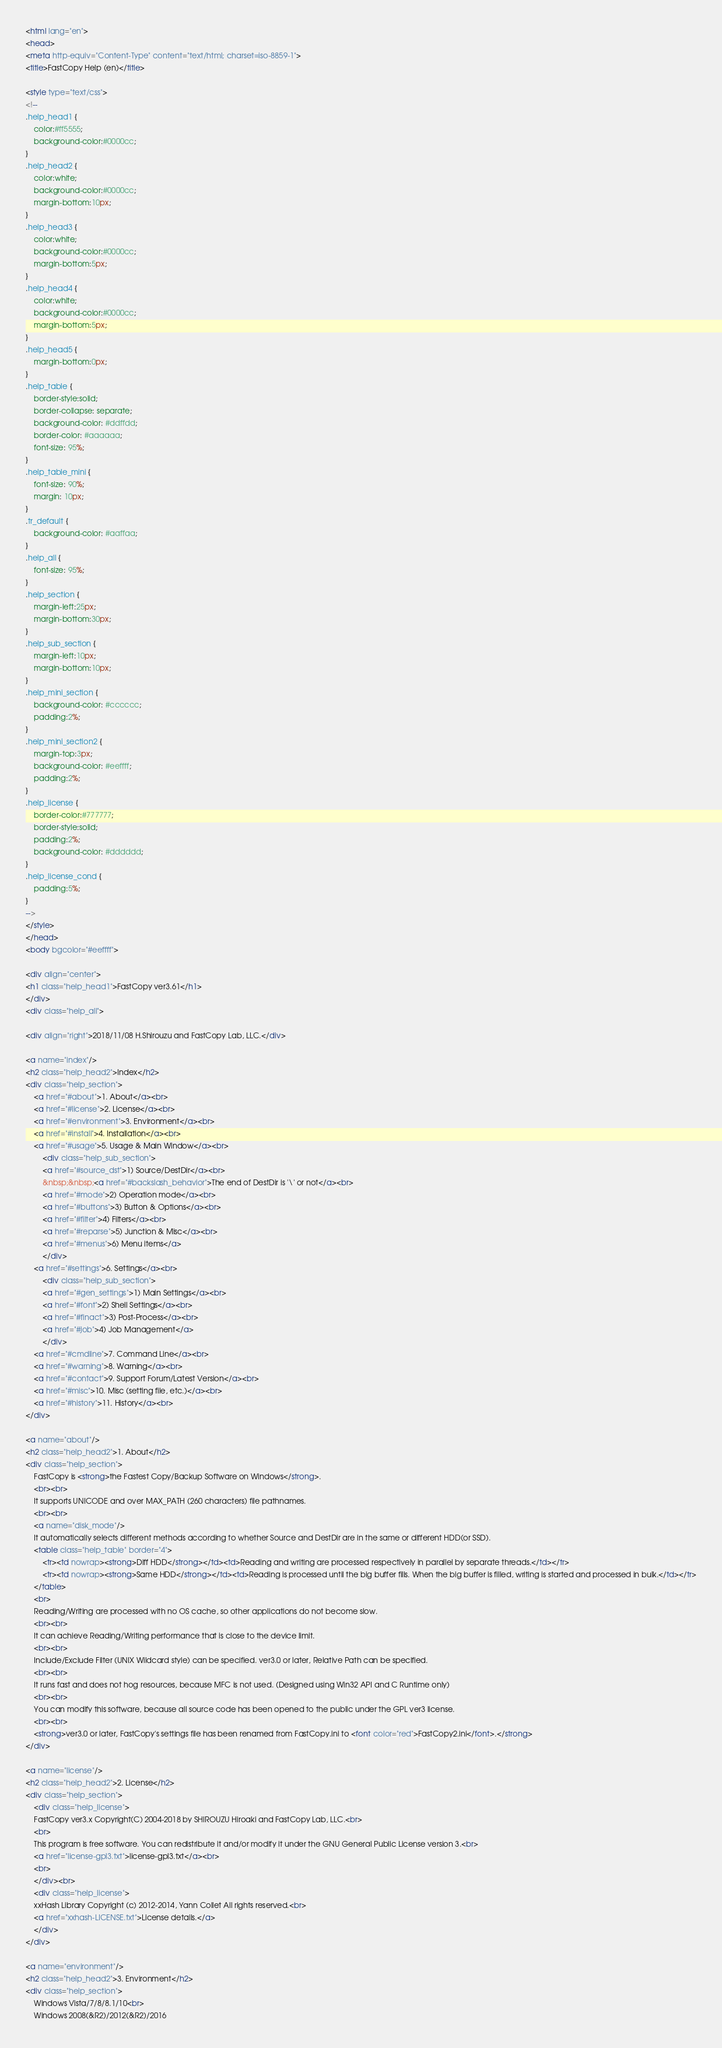<code> <loc_0><loc_0><loc_500><loc_500><_HTML_><html lang="en">
<head>
<meta http-equiv="Content-Type" content="text/html; charset=iso-8859-1">
<title>FastCopy Help (en)</title>

<style type="text/css">
<!--
.help_head1 {
	color:#ff5555;
	background-color:#0000cc;
}
.help_head2 {
	color:white;
	background-color:#0000cc;
	margin-bottom:10px;
}
.help_head3 {
	color:white;
	background-color:#0000cc;
	margin-bottom:5px;
}
.help_head4 {
	color:white;
	background-color:#0000cc;
	margin-bottom:5px;
}
.help_head5 {
	margin-bottom:0px;
}
.help_table {
	border-style:solid;
	border-collapse: separate;
	background-color: #ddffdd;
	border-color: #aaaaaa;
	font-size: 95%;
}
.help_table_mini {
	font-size: 90%;
	margin: 10px;
}
.tr_default {
	background-color: #aaffaa;
}
.help_all {
	font-size: 95%;
}
.help_section {
	margin-left:25px;
	margin-bottom:30px;
}
.help_sub_section {
	margin-left:10px;
	margin-bottom:10px;
}
.help_mini_section {
	background-color: #cccccc;
	padding:2%;
}
.help_mini_section2 {
	margin-top:3px;
	background-color: #eeffff;
	padding:2%;
}
.help_license {
	border-color:#777777; 
	border-style:solid; 
	padding:2%;
	background-color: #dddddd;
}
.help_license_cond {
	padding:5%;
}
-->
</style>
</head>
<body bgcolor="#eeffff">

<div align="center">
<h1 class="help_head1">FastCopy ver3.61</h1>
</div>
<div class="help_all">

<div align="right">2018/11/08 H.Shirouzu and FastCopy Lab, LLC.</div>

<a name="index"/>
<h2 class="help_head2">Index</h2>
<div class="help_section">
	<a href="#about">1. About</a><br>
	<a href="#license">2. License</a><br>
	<a href="#environment">3. Environment</a><br>
	<a href="#install">4. Installation</a><br>
	<a href="#usage">5. Usage & Main Window</a><br>
		<div class="help_sub_section">
		<a href="#source_dst">1) Source/DestDir</a><br>
		&nbsp;&nbsp;<a href="#backslash_behavior">The end of DestDir is '\' or not</a><br>
		<a href="#mode">2) Operation mode</a><br>
		<a href="#buttons">3) Button & Options</a><br>
		<a href="#filter">4) Filters</a><br>
		<a href="#reparse">5) Junction & Misc</a><br>
		<a href="#menus">6) Menu items</a>
		</div>
	<a href="#settings">6. Settings</a><br>
		<div class="help_sub_section">
		<a href="#gen_settings">1) Main Settings</a><br>
		<a href="#font">2) Shell Settings</a><br>
		<a href="#finact">3) Post-Process</a><br>
		<a href="#job">4) Job Management</a>
		</div>
	<a href="#cmdline">7. Command Line</a><br>
	<a href="#warning">8. Warning</a><br>
	<a href="#contact">9. Support Forum/Latest Version</a><br>
	<a href="#misc">10. Misc (setting file, etc.)</a><br>
	<a href="#history">11. History</a><br>
</div>

<a name="about"/>
<h2 class="help_head2">1. About</h2>
<div class="help_section">
	FastCopy is <strong>the Fastest Copy/Backup Software on Windows</strong>.
	<br><br>
	It supports UNICODE and over MAX_PATH (260 characters) file pathnames.
	<br><br>
	<a name="disk_mode"/>
	It automatically selects different methods according to whether Source and DestDir are in the same or different HDD(or SSD).
	<table class="help_table" border="4">
		<tr><td nowrap><strong>Diff HDD</strong></td><td>Reading and writing are processed respectively in parallel by separate threads.</td></tr>
		<tr><td nowrap><strong>Same HDD</strong></td><td>Reading is processed until the big buffer fills. When the big buffer is filled, writing is started and processed in bulk.</td></tr>
	</table>
	<br>
	Reading/Writing are processed with no OS cache, so other applications do not become slow.
	<br><br>
	It can achieve Reading/Writing performance that is close to the device limit.
	<br><br>
	Include/Exclude Filter (UNIX Wildcard style) can be specified. ver3.0 or later, Relative Path can be specified.
	<br><br>
	It runs fast and does not hog resources, because MFC is not used. (Designed using Win32 API and C Runtime only) 
	<br><br>
	You can modify this software, because all source code has been opened to the public under the GPL ver3 license. 
	<br><br>
	<strong>ver3.0 or later, FastCopy's settings file has been renamed from FastCopy.ini to <font color="red">FastCopy2.ini</font>.</strong>
</div>

<a name="license"/>
<h2 class="help_head2">2. License</h2>
<div class="help_section">
	<div class="help_license">
	FastCopy ver3.x Copyright(C) 2004-2018 by SHIROUZU Hiroaki and FastCopy Lab, LLC.<br>
	<br>
	This program is free software. You can redistribute it and/or modify it under the GNU General Public License version 3.<br>
	<a href="license-gpl3.txt">license-gpl3.txt</a><br>
	<br>
	</div><br>
	<div class="help_license">
	xxHash Library Copyright (c) 2012-2014, Yann Collet All rights reserved.<br>
	<a href="xxhash-LICENSE.txt">License details.</a>
	</div>
</div>

<a name="environment"/>
<h2 class="help_head2">3. Environment</h2>
<div class="help_section">
	Windows Vista/7/8/8.1/10<br>
	Windows 2008(&R2)/2012(&R2)/2016</code> 